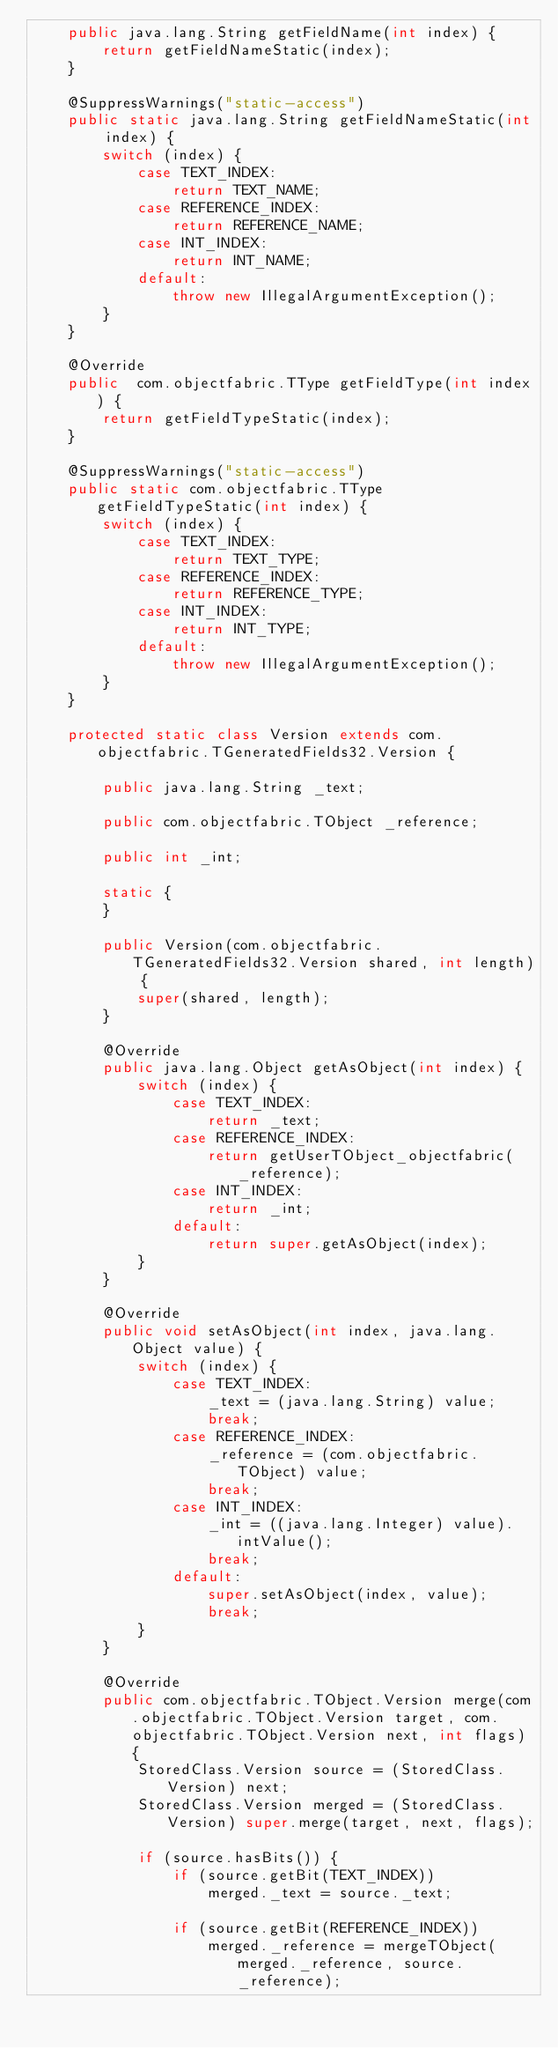<code> <loc_0><loc_0><loc_500><loc_500><_Java_>    public java.lang.String getFieldName(int index) {
        return getFieldNameStatic(index);
    }

    @SuppressWarnings("static-access")
    public static java.lang.String getFieldNameStatic(int index) {
        switch (index) {
            case TEXT_INDEX:
                return TEXT_NAME;
            case REFERENCE_INDEX:
                return REFERENCE_NAME;
            case INT_INDEX:
                return INT_NAME;
            default:
                throw new IllegalArgumentException();
        }
    }

    @Override
    public  com.objectfabric.TType getFieldType(int index) {
        return getFieldTypeStatic(index);
    }

    @SuppressWarnings("static-access")
    public static com.objectfabric.TType getFieldTypeStatic(int index) {
        switch (index) {
            case TEXT_INDEX:
                return TEXT_TYPE;
            case REFERENCE_INDEX:
                return REFERENCE_TYPE;
            case INT_INDEX:
                return INT_TYPE;
            default:
                throw new IllegalArgumentException();
        }
    }

    protected static class Version extends com.objectfabric.TGeneratedFields32.Version {

        public java.lang.String _text;

        public com.objectfabric.TObject _reference;

        public int _int;

        static {
        }

        public Version(com.objectfabric.TGeneratedFields32.Version shared, int length) {
            super(shared, length);
        }

        @Override
        public java.lang.Object getAsObject(int index) {
            switch (index) {
                case TEXT_INDEX:
                    return _text;
                case REFERENCE_INDEX:
                    return getUserTObject_objectfabric(_reference);
                case INT_INDEX:
                    return _int;
                default:
                    return super.getAsObject(index);
            }
        }

        @Override
        public void setAsObject(int index, java.lang.Object value) {
            switch (index) {
                case TEXT_INDEX:
                    _text = (java.lang.String) value;
                    break;
                case REFERENCE_INDEX:
                    _reference = (com.objectfabric.TObject) value;
                    break;
                case INT_INDEX:
                    _int = ((java.lang.Integer) value).intValue();
                    break;
                default:
                    super.setAsObject(index, value);
                    break;
            }
        }

        @Override
        public com.objectfabric.TObject.Version merge(com.objectfabric.TObject.Version target, com.objectfabric.TObject.Version next, int flags) {
            StoredClass.Version source = (StoredClass.Version) next;
            StoredClass.Version merged = (StoredClass.Version) super.merge(target, next, flags);

            if (source.hasBits()) {
                if (source.getBit(TEXT_INDEX))
                    merged._text = source._text;

                if (source.getBit(REFERENCE_INDEX))
                    merged._reference = mergeTObject(merged._reference, source._reference);
</code> 